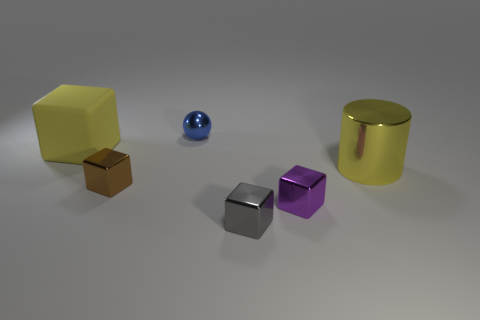Subtract all green balls. Subtract all cyan cubes. How many balls are left? 1 Add 4 green rubber things. How many objects exist? 10 Subtract all blocks. How many objects are left? 2 Add 3 matte blocks. How many matte blocks are left? 4 Add 2 purple metal blocks. How many purple metal blocks exist? 3 Subtract 0 green blocks. How many objects are left? 6 Subtract all tiny purple shiny blocks. Subtract all gray metal cubes. How many objects are left? 4 